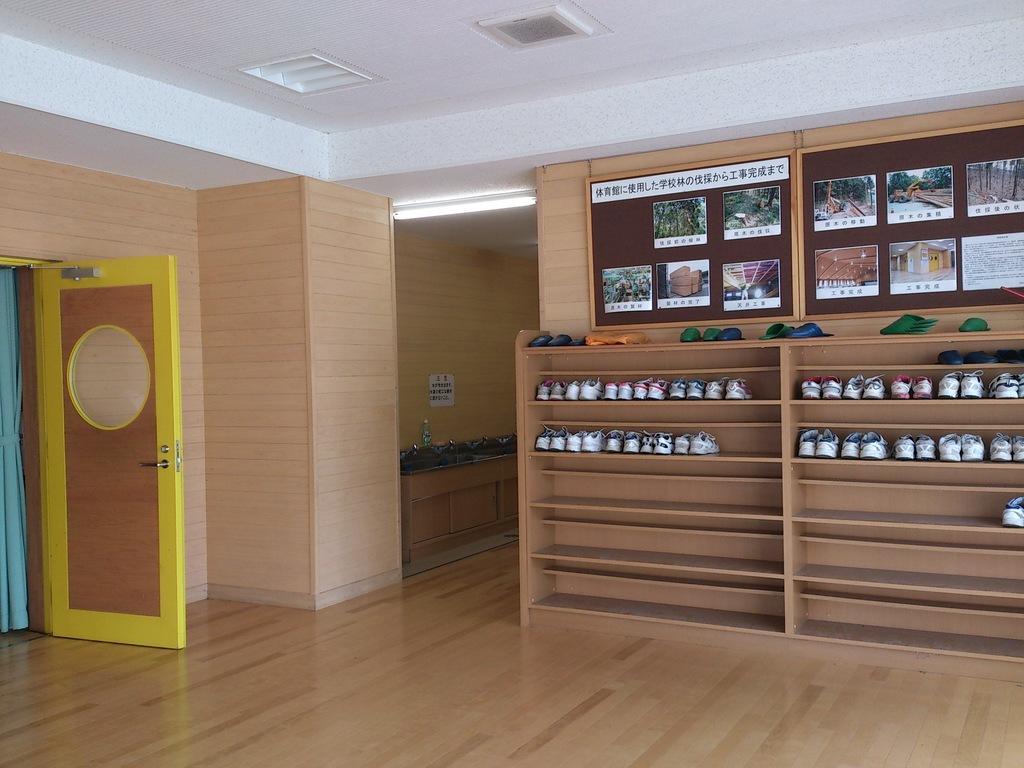Could you give a brief overview of what you see in this image? In this image we can see shoes on the racks. Also there are boards with images. On the left side there is a door and curtain. On the ceiling there is light. In the back there is a cupboard. On that there is a bottle and some other items. On the wall something is pasted. 